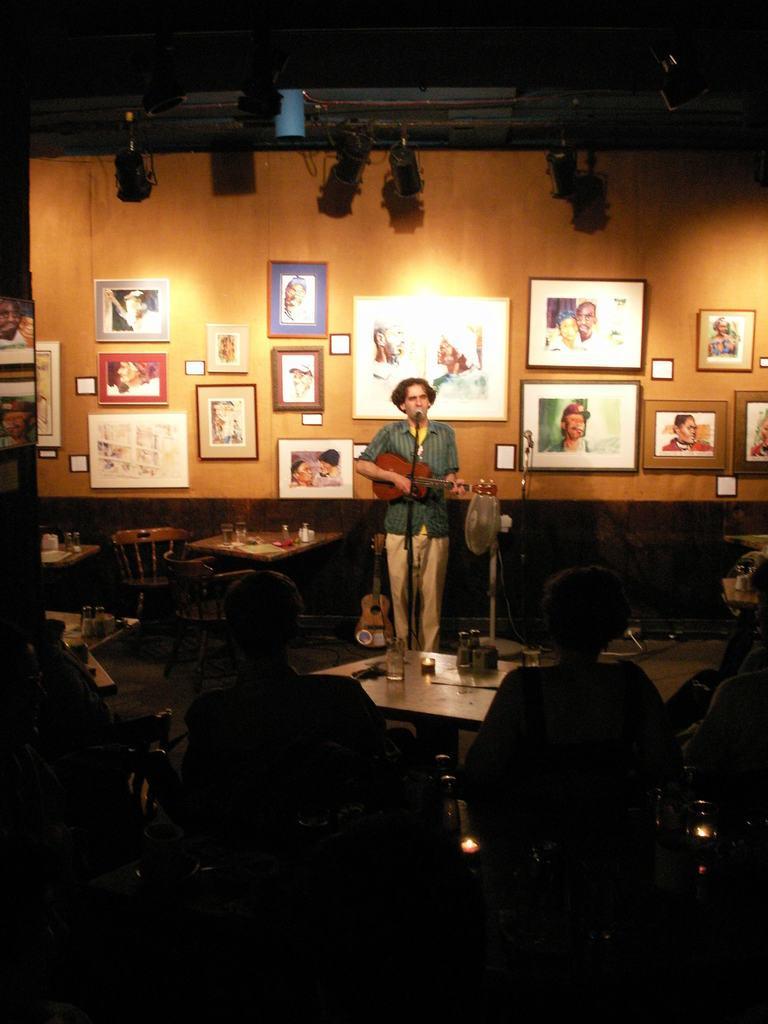In one or two sentences, can you explain what this image depicts? In this image i can see a woman standing and playing guitar in front of her there is a micro phone at the back ground i can see few frames attached to a wooden wall, at left there are few glasses on a table and two chairs, there are two persons sitting on a chair, the woman wearing a blue shirt and a cream pant. 